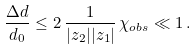Convert formula to latex. <formula><loc_0><loc_0><loc_500><loc_500>\frac { \Delta d } { d _ { 0 } } \leq 2 \, \frac { 1 } { | z _ { 2 } | | z _ { 1 } | } \, \chi _ { o b s } \ll 1 \, .</formula> 